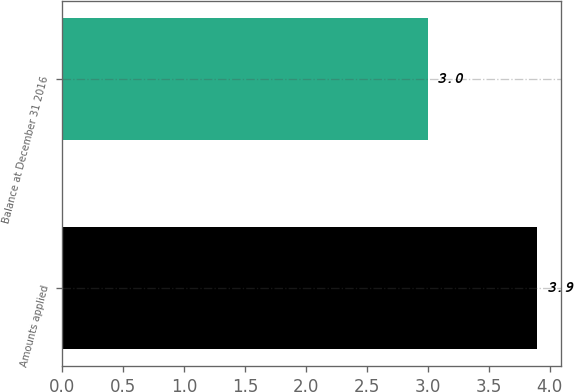Convert chart to OTSL. <chart><loc_0><loc_0><loc_500><loc_500><bar_chart><fcel>Amounts applied<fcel>Balance at December 31 2016<nl><fcel>3.9<fcel>3<nl></chart> 